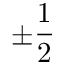<formula> <loc_0><loc_0><loc_500><loc_500>\pm \frac { 1 } { 2 }</formula> 